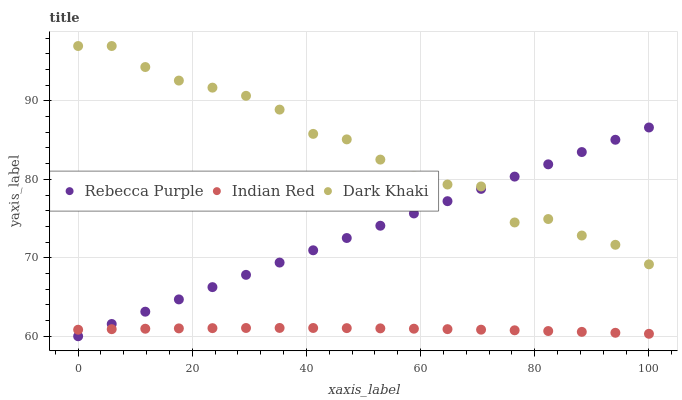Does Indian Red have the minimum area under the curve?
Answer yes or no. Yes. Does Dark Khaki have the maximum area under the curve?
Answer yes or no. Yes. Does Rebecca Purple have the minimum area under the curve?
Answer yes or no. No. Does Rebecca Purple have the maximum area under the curve?
Answer yes or no. No. Is Rebecca Purple the smoothest?
Answer yes or no. Yes. Is Dark Khaki the roughest?
Answer yes or no. Yes. Is Indian Red the smoothest?
Answer yes or no. No. Is Indian Red the roughest?
Answer yes or no. No. Does Rebecca Purple have the lowest value?
Answer yes or no. Yes. Does Indian Red have the lowest value?
Answer yes or no. No. Does Dark Khaki have the highest value?
Answer yes or no. Yes. Does Rebecca Purple have the highest value?
Answer yes or no. No. Is Indian Red less than Dark Khaki?
Answer yes or no. Yes. Is Dark Khaki greater than Indian Red?
Answer yes or no. Yes. Does Indian Red intersect Rebecca Purple?
Answer yes or no. Yes. Is Indian Red less than Rebecca Purple?
Answer yes or no. No. Is Indian Red greater than Rebecca Purple?
Answer yes or no. No. Does Indian Red intersect Dark Khaki?
Answer yes or no. No. 